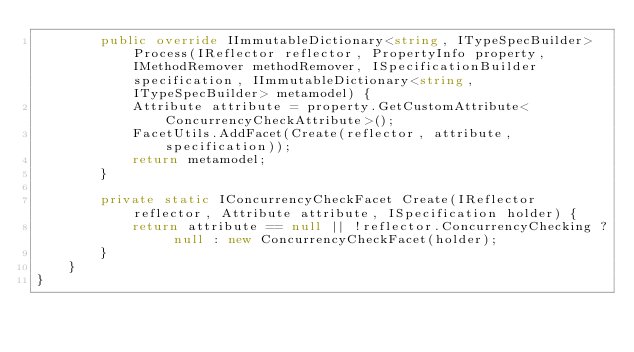<code> <loc_0><loc_0><loc_500><loc_500><_C#_>        public override IImmutableDictionary<string, ITypeSpecBuilder> Process(IReflector reflector, PropertyInfo property, IMethodRemover methodRemover, ISpecificationBuilder specification, IImmutableDictionary<string, ITypeSpecBuilder> metamodel) {
            Attribute attribute = property.GetCustomAttribute<ConcurrencyCheckAttribute>();
            FacetUtils.AddFacet(Create(reflector, attribute, specification));
            return metamodel;
        }

        private static IConcurrencyCheckFacet Create(IReflector reflector, Attribute attribute, ISpecification holder) {
            return attribute == null || !reflector.ConcurrencyChecking ? null : new ConcurrencyCheckFacet(holder);
        }
    }
}</code> 